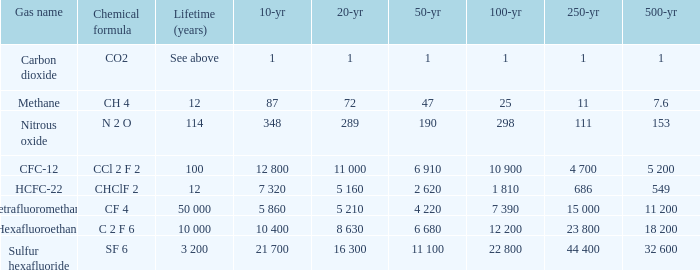What is the 20 year for Sulfur Hexafluoride? 16 300. 